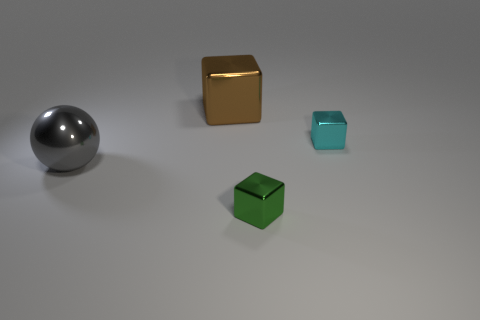Subtract all tiny blocks. How many blocks are left? 1 Subtract all cyan blocks. How many blocks are left? 2 Subtract 2 cubes. How many cubes are left? 1 Subtract all blue blocks. Subtract all yellow cylinders. How many blocks are left? 3 Subtract all yellow cylinders. How many cyan blocks are left? 1 Subtract all green metallic blocks. Subtract all green cubes. How many objects are left? 2 Add 3 tiny cyan blocks. How many tiny cyan blocks are left? 4 Add 1 balls. How many balls exist? 2 Add 4 small cyan metallic objects. How many objects exist? 8 Subtract 0 purple balls. How many objects are left? 4 